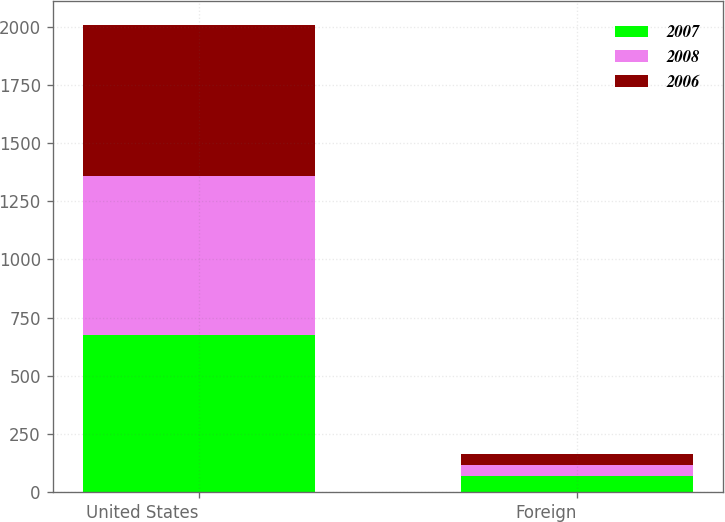<chart> <loc_0><loc_0><loc_500><loc_500><stacked_bar_chart><ecel><fcel>United States<fcel>Foreign<nl><fcel>2007<fcel>676.3<fcel>69.6<nl><fcel>2008<fcel>681.2<fcel>46.6<nl><fcel>2006<fcel>649.8<fcel>48.8<nl></chart> 